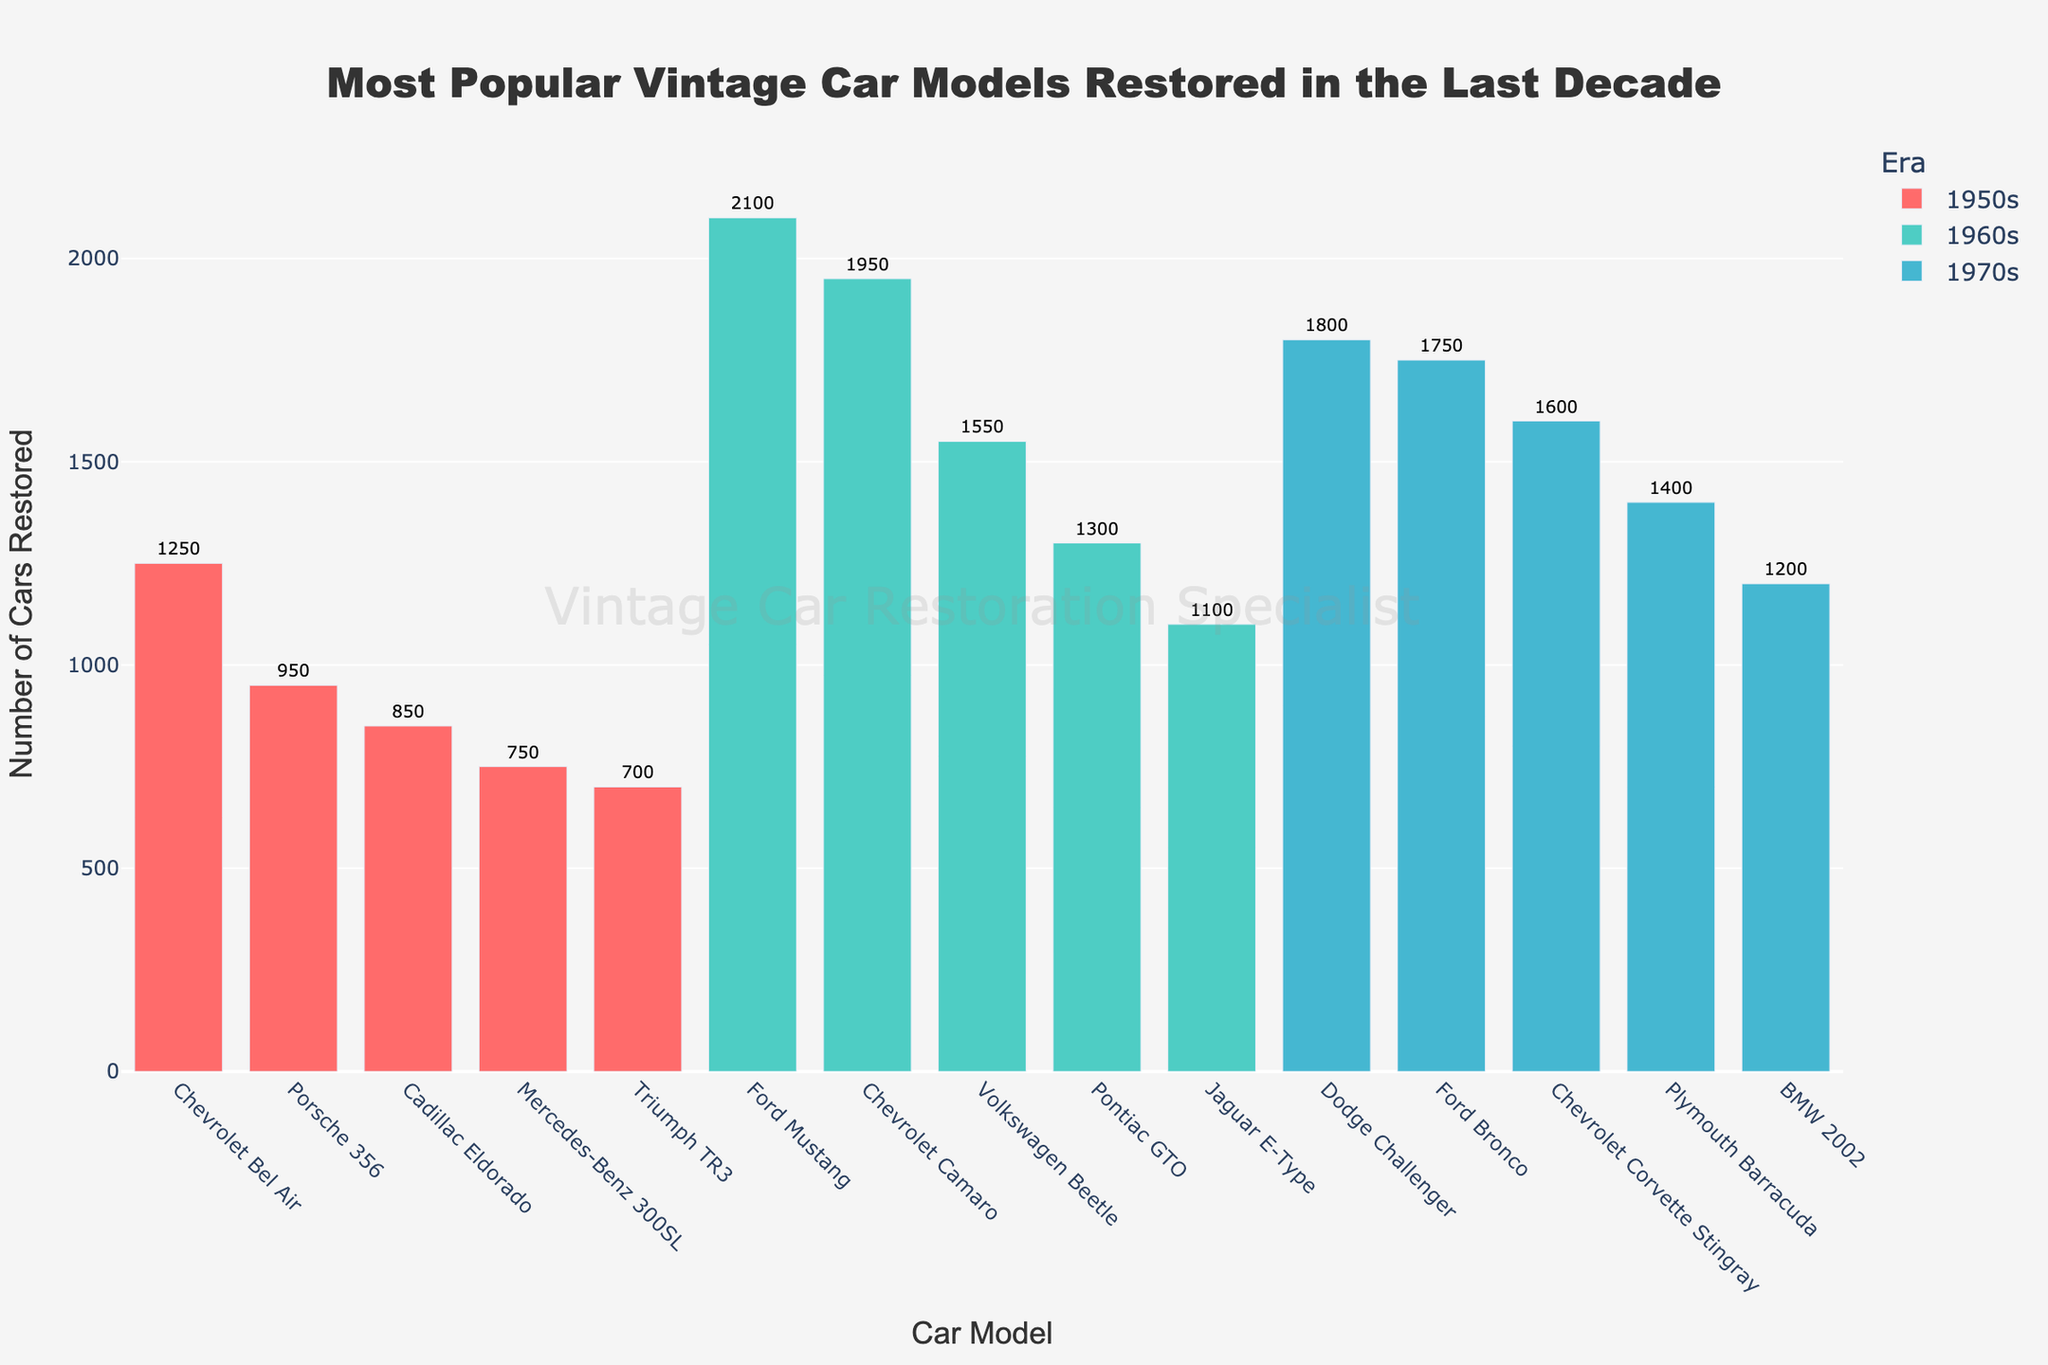Which car model from the 1960s had the highest number of restorations? To determine this, look at the heights of the bars for the cars from the 1960s (color-coded) in the figure, and identify the one with the tallest bar. This is the Ford Mustang, with 2100 restorations.
Answer: Ford Mustang Which era had the most number of cars restored? Sum the total number of restorations for each era and compare. For 1950s: 1250+950+750+850+700=4500, for 1960s: 2100 + 1950 + 1100 + 1300 + 1550 = 8000, for 1970s: 1800 + 1600 + 1400 + 1750 + 1200 = 7750. The 1960s had the highest total number.
Answer: 1960s How many more restorations did the Ford Mustang have compared to the Chevrolet Camaro? Check the restoration numbers of both models: Ford Mustang had 2100 restorations; Chevrolet Camaro had 1950. Subtract 1950 from 2100.
Answer: 150 Which model from the 1970s was restored the most? Look at the heights of the bars for the 1970s models (color-coded) and identify the tallest bar. It indicates the Dodge Challenger with 1800 restorations.
Answer: Dodge Challenger What is the total number of cars restored from the 1950s? Sum up the restorations listed for each 1950s model: 1250 (Chevrolet Bel Air) + 950 (Porsche 356) + 750 (Mercedes-Benz 300SL) + 850 (Cadillac Eldorado) + 700 (Triumph TR3) = 4500.
Answer: 4500 How many vintage car models from the 1960s had more than 1500 restorations? Identify the 1960s models which had restoration values greater than 1500 and count them. These are the Ford Mustang (2100), Chevrolet Camaro (1950), and Volkswagen Beetle (1550) - 3 models in total.
Answer: 3 Which car model from the 1950s had the fewest restorations? Look at the heights of the bars for the cars from the 1950s and identify the shortest one. This is the Triumph TR3 with 700 restorations.
Answer: Triumph TR3 What is the difference in the number of restorations between the most restored car from the 1970s and the least restored car from the 1950s? The most restored car from the 1970s is the Dodge Challenger with 1800 restorations. The least restored car from the 1950s is the Triumph TR3 with 700 restorations. Calculate the difference: 1800 - 700 = 1100.
Answer: 1100 Which era had the widest range of restored car models? Calculate the range (difference between the highest and lowest restoration numbers) for each era. For 1950s: 1250 (Chevrolet Bel Air) - 700 (Triumph TR3) = 550, for 1960s: 2100 (Ford Mustang) - 1100 (Jaguar E-Type) = 1000, for 1970s: 1800 (Dodge Challenger) - 1200 (BMW 2002) = 600. The 1960s had the widest range.
Answer: 1960s 